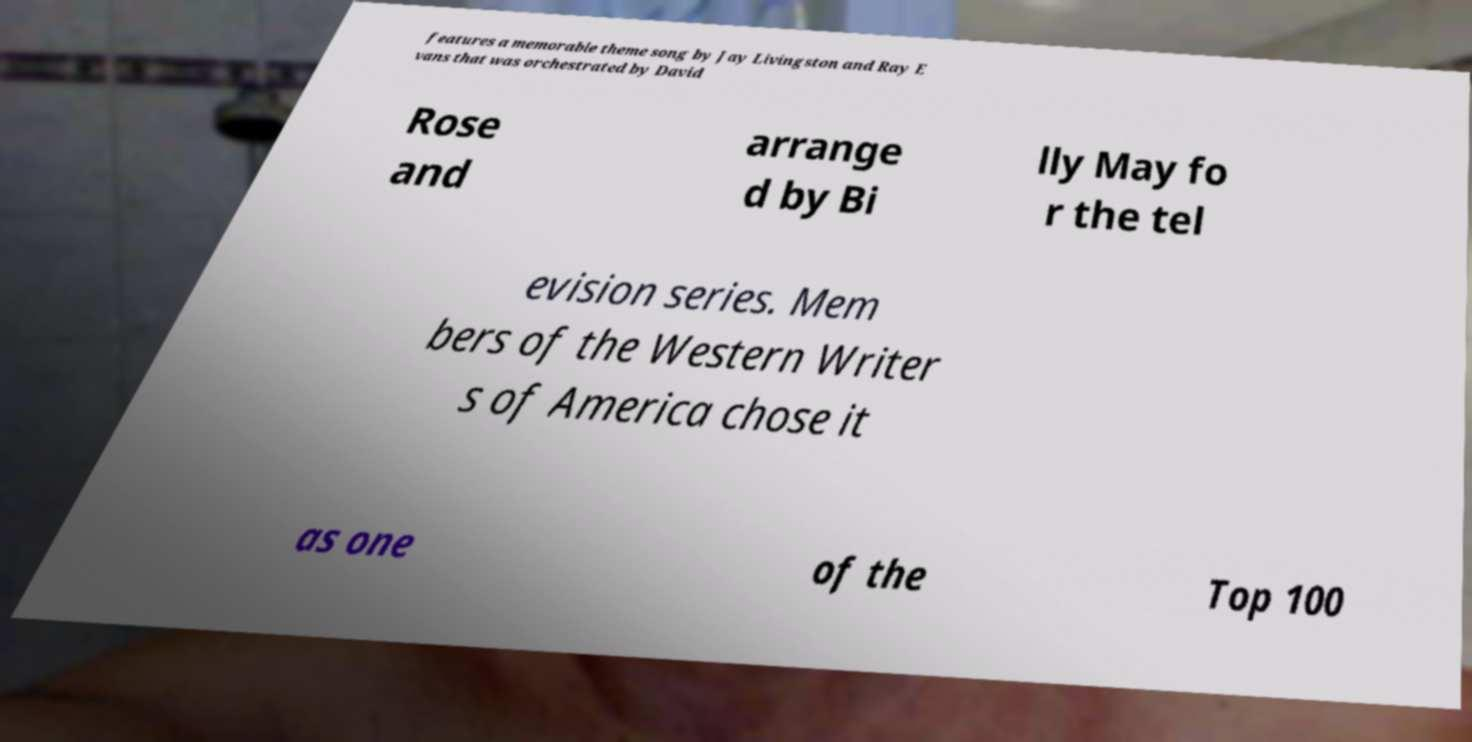Can you accurately transcribe the text from the provided image for me? features a memorable theme song by Jay Livingston and Ray E vans that was orchestrated by David Rose and arrange d by Bi lly May fo r the tel evision series. Mem bers of the Western Writer s of America chose it as one of the Top 100 